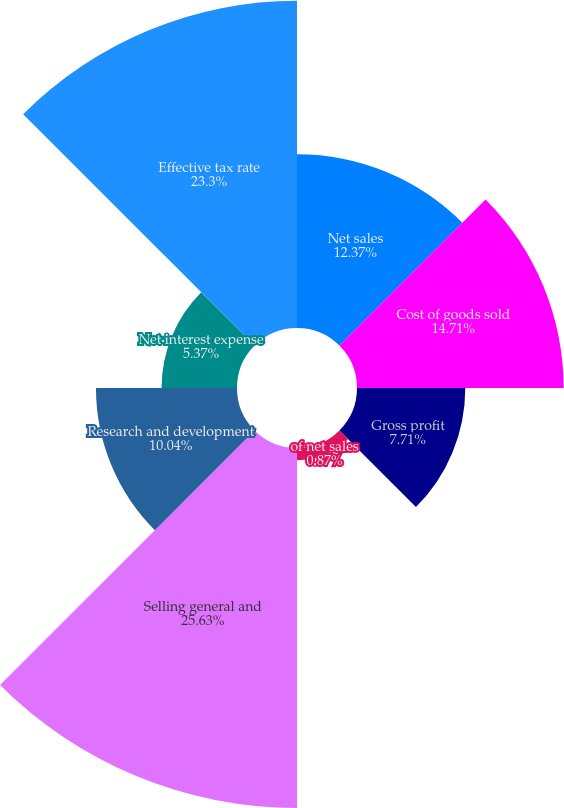<chart> <loc_0><loc_0><loc_500><loc_500><pie_chart><fcel>Net sales<fcel>Cost of goods sold<fcel>Gross profit<fcel>of net sales<fcel>Selling general and<fcel>Research and development<fcel>Net interest expense<fcel>Effective tax rate<nl><fcel>12.37%<fcel>14.71%<fcel>7.71%<fcel>0.87%<fcel>25.63%<fcel>10.04%<fcel>5.37%<fcel>23.3%<nl></chart> 